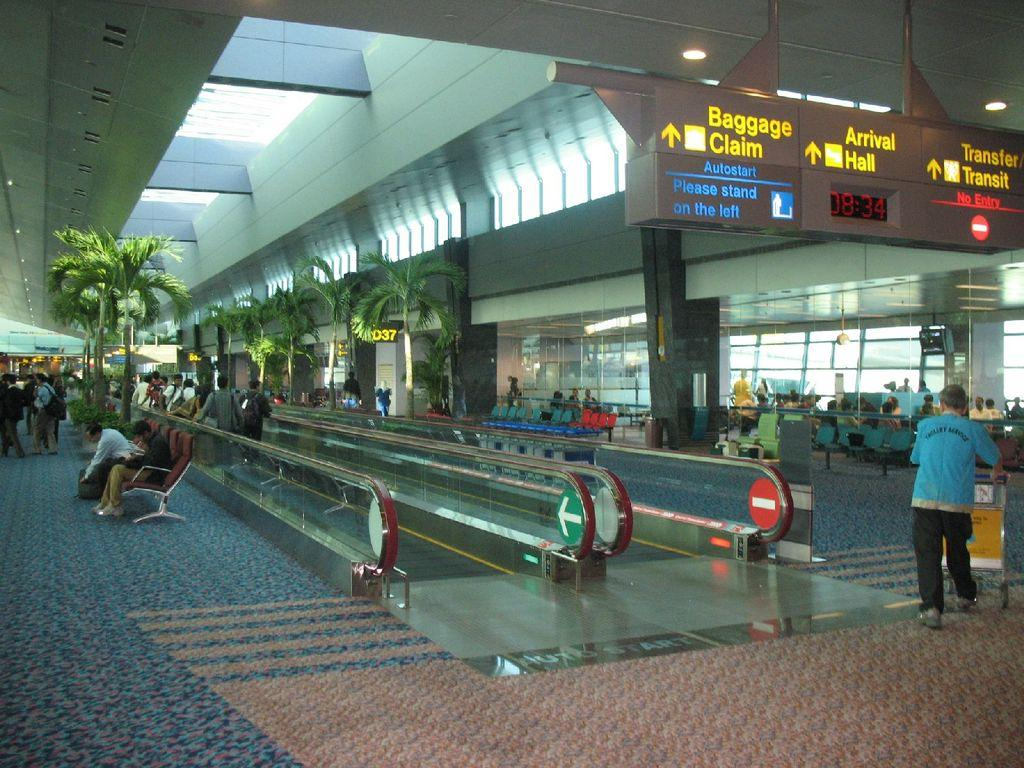What are the people in the image doing? There are persons sitting and walking in the image. What can be seen in the background of the image? There are trees in the image. What type of signage is present in the image? There are boards with text in the image. What furniture is visible in the image? There are empty chairs in the image. What architectural features can be seen in the image? There are windows, pillars, and lights in the image. Can you tell me how many beggars are present in the image? There are no beggars present in the image. What type of sport is being played in the image? There is no sport being played in the image; it does not feature any baseball or related equipment. 